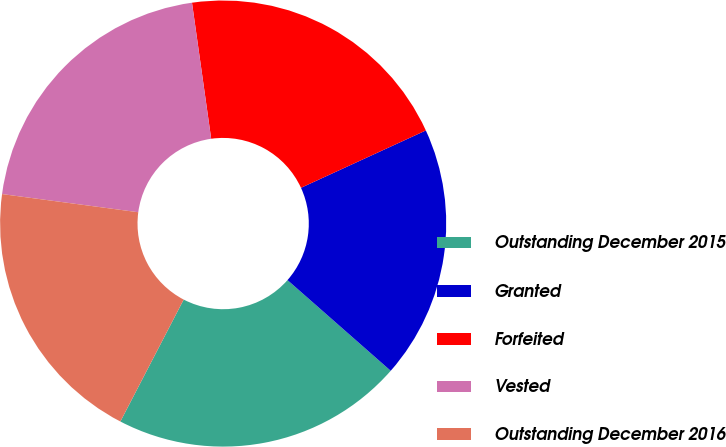Convert chart. <chart><loc_0><loc_0><loc_500><loc_500><pie_chart><fcel>Outstanding December 2015<fcel>Granted<fcel>Forfeited<fcel>Vested<fcel>Outstanding December 2016<nl><fcel>21.15%<fcel>18.33%<fcel>20.38%<fcel>20.66%<fcel>19.49%<nl></chart> 